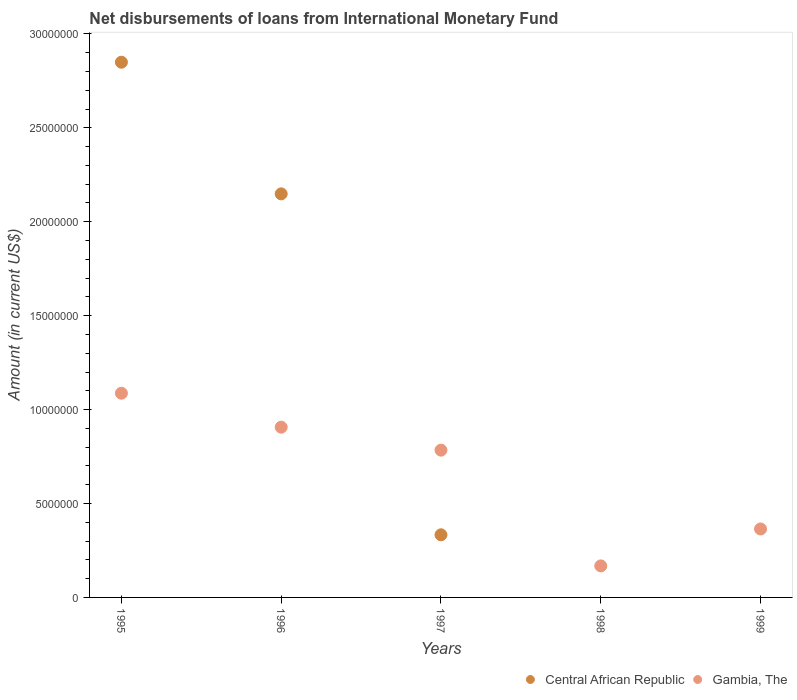Is the number of dotlines equal to the number of legend labels?
Your answer should be very brief. No. What is the amount of loans disbursed in Gambia, The in 1996?
Your response must be concise. 9.06e+06. Across all years, what is the maximum amount of loans disbursed in Central African Republic?
Provide a succinct answer. 2.85e+07. Across all years, what is the minimum amount of loans disbursed in Gambia, The?
Make the answer very short. 1.68e+06. What is the total amount of loans disbursed in Gambia, The in the graph?
Give a very brief answer. 3.31e+07. What is the difference between the amount of loans disbursed in Gambia, The in 1997 and that in 1999?
Provide a short and direct response. 4.20e+06. What is the difference between the amount of loans disbursed in Central African Republic in 1997 and the amount of loans disbursed in Gambia, The in 1995?
Make the answer very short. -7.54e+06. What is the average amount of loans disbursed in Gambia, The per year?
Your response must be concise. 6.62e+06. In the year 1997, what is the difference between the amount of loans disbursed in Central African Republic and amount of loans disbursed in Gambia, The?
Your answer should be compact. -4.51e+06. What is the ratio of the amount of loans disbursed in Gambia, The in 1996 to that in 1998?
Provide a short and direct response. 5.4. What is the difference between the highest and the second highest amount of loans disbursed in Gambia, The?
Offer a terse response. 1.81e+06. What is the difference between the highest and the lowest amount of loans disbursed in Central African Republic?
Keep it short and to the point. 2.85e+07. How many dotlines are there?
Your answer should be very brief. 2. How many years are there in the graph?
Offer a very short reply. 5. What is the difference between two consecutive major ticks on the Y-axis?
Provide a succinct answer. 5.00e+06. Does the graph contain grids?
Your response must be concise. No. Where does the legend appear in the graph?
Keep it short and to the point. Bottom right. How many legend labels are there?
Offer a very short reply. 2. How are the legend labels stacked?
Provide a succinct answer. Horizontal. What is the title of the graph?
Keep it short and to the point. Net disbursements of loans from International Monetary Fund. Does "Japan" appear as one of the legend labels in the graph?
Provide a short and direct response. No. What is the label or title of the X-axis?
Make the answer very short. Years. What is the Amount (in current US$) in Central African Republic in 1995?
Your answer should be very brief. 2.85e+07. What is the Amount (in current US$) in Gambia, The in 1995?
Ensure brevity in your answer.  1.09e+07. What is the Amount (in current US$) of Central African Republic in 1996?
Provide a succinct answer. 2.15e+07. What is the Amount (in current US$) of Gambia, The in 1996?
Your answer should be compact. 9.06e+06. What is the Amount (in current US$) of Central African Republic in 1997?
Make the answer very short. 3.33e+06. What is the Amount (in current US$) in Gambia, The in 1997?
Offer a terse response. 7.84e+06. What is the Amount (in current US$) in Gambia, The in 1998?
Make the answer very short. 1.68e+06. What is the Amount (in current US$) of Central African Republic in 1999?
Keep it short and to the point. 0. What is the Amount (in current US$) of Gambia, The in 1999?
Your answer should be compact. 3.64e+06. Across all years, what is the maximum Amount (in current US$) in Central African Republic?
Give a very brief answer. 2.85e+07. Across all years, what is the maximum Amount (in current US$) of Gambia, The?
Make the answer very short. 1.09e+07. Across all years, what is the minimum Amount (in current US$) in Central African Republic?
Your answer should be compact. 0. Across all years, what is the minimum Amount (in current US$) of Gambia, The?
Provide a short and direct response. 1.68e+06. What is the total Amount (in current US$) in Central African Republic in the graph?
Ensure brevity in your answer.  5.33e+07. What is the total Amount (in current US$) of Gambia, The in the graph?
Your answer should be compact. 3.31e+07. What is the difference between the Amount (in current US$) in Central African Republic in 1995 and that in 1996?
Provide a succinct answer. 7.01e+06. What is the difference between the Amount (in current US$) of Gambia, The in 1995 and that in 1996?
Offer a terse response. 1.81e+06. What is the difference between the Amount (in current US$) in Central African Republic in 1995 and that in 1997?
Make the answer very short. 2.52e+07. What is the difference between the Amount (in current US$) of Gambia, The in 1995 and that in 1997?
Offer a very short reply. 3.03e+06. What is the difference between the Amount (in current US$) in Gambia, The in 1995 and that in 1998?
Your response must be concise. 9.19e+06. What is the difference between the Amount (in current US$) of Gambia, The in 1995 and that in 1999?
Your response must be concise. 7.23e+06. What is the difference between the Amount (in current US$) of Central African Republic in 1996 and that in 1997?
Provide a succinct answer. 1.82e+07. What is the difference between the Amount (in current US$) in Gambia, The in 1996 and that in 1997?
Provide a short and direct response. 1.22e+06. What is the difference between the Amount (in current US$) of Gambia, The in 1996 and that in 1998?
Make the answer very short. 7.38e+06. What is the difference between the Amount (in current US$) of Gambia, The in 1996 and that in 1999?
Give a very brief answer. 5.42e+06. What is the difference between the Amount (in current US$) in Gambia, The in 1997 and that in 1998?
Make the answer very short. 6.16e+06. What is the difference between the Amount (in current US$) of Gambia, The in 1997 and that in 1999?
Your response must be concise. 4.20e+06. What is the difference between the Amount (in current US$) of Gambia, The in 1998 and that in 1999?
Your answer should be compact. -1.97e+06. What is the difference between the Amount (in current US$) of Central African Republic in 1995 and the Amount (in current US$) of Gambia, The in 1996?
Your answer should be compact. 1.94e+07. What is the difference between the Amount (in current US$) of Central African Republic in 1995 and the Amount (in current US$) of Gambia, The in 1997?
Offer a terse response. 2.07e+07. What is the difference between the Amount (in current US$) in Central African Republic in 1995 and the Amount (in current US$) in Gambia, The in 1998?
Provide a short and direct response. 2.68e+07. What is the difference between the Amount (in current US$) in Central African Republic in 1995 and the Amount (in current US$) in Gambia, The in 1999?
Your answer should be very brief. 2.48e+07. What is the difference between the Amount (in current US$) of Central African Republic in 1996 and the Amount (in current US$) of Gambia, The in 1997?
Provide a succinct answer. 1.36e+07. What is the difference between the Amount (in current US$) of Central African Republic in 1996 and the Amount (in current US$) of Gambia, The in 1998?
Your answer should be compact. 1.98e+07. What is the difference between the Amount (in current US$) of Central African Republic in 1996 and the Amount (in current US$) of Gambia, The in 1999?
Your answer should be very brief. 1.78e+07. What is the difference between the Amount (in current US$) of Central African Republic in 1997 and the Amount (in current US$) of Gambia, The in 1998?
Ensure brevity in your answer.  1.66e+06. What is the difference between the Amount (in current US$) in Central African Republic in 1997 and the Amount (in current US$) in Gambia, The in 1999?
Offer a terse response. -3.11e+05. What is the average Amount (in current US$) of Central African Republic per year?
Your response must be concise. 1.07e+07. What is the average Amount (in current US$) of Gambia, The per year?
Keep it short and to the point. 6.62e+06. In the year 1995, what is the difference between the Amount (in current US$) in Central African Republic and Amount (in current US$) in Gambia, The?
Keep it short and to the point. 1.76e+07. In the year 1996, what is the difference between the Amount (in current US$) of Central African Republic and Amount (in current US$) of Gambia, The?
Ensure brevity in your answer.  1.24e+07. In the year 1997, what is the difference between the Amount (in current US$) in Central African Republic and Amount (in current US$) in Gambia, The?
Make the answer very short. -4.51e+06. What is the ratio of the Amount (in current US$) of Central African Republic in 1995 to that in 1996?
Offer a very short reply. 1.33. What is the ratio of the Amount (in current US$) in Gambia, The in 1995 to that in 1996?
Your response must be concise. 1.2. What is the ratio of the Amount (in current US$) of Central African Republic in 1995 to that in 1997?
Ensure brevity in your answer.  8.55. What is the ratio of the Amount (in current US$) of Gambia, The in 1995 to that in 1997?
Give a very brief answer. 1.39. What is the ratio of the Amount (in current US$) of Gambia, The in 1995 to that in 1998?
Keep it short and to the point. 6.48. What is the ratio of the Amount (in current US$) in Gambia, The in 1995 to that in 1999?
Give a very brief answer. 2.98. What is the ratio of the Amount (in current US$) of Central African Republic in 1996 to that in 1997?
Offer a very short reply. 6.44. What is the ratio of the Amount (in current US$) in Gambia, The in 1996 to that in 1997?
Provide a succinct answer. 1.16. What is the ratio of the Amount (in current US$) in Gambia, The in 1996 to that in 1998?
Your answer should be very brief. 5.4. What is the ratio of the Amount (in current US$) of Gambia, The in 1996 to that in 1999?
Make the answer very short. 2.49. What is the ratio of the Amount (in current US$) of Gambia, The in 1997 to that in 1998?
Your response must be concise. 4.67. What is the ratio of the Amount (in current US$) in Gambia, The in 1997 to that in 1999?
Your response must be concise. 2.15. What is the ratio of the Amount (in current US$) in Gambia, The in 1998 to that in 1999?
Your answer should be very brief. 0.46. What is the difference between the highest and the second highest Amount (in current US$) in Central African Republic?
Provide a short and direct response. 7.01e+06. What is the difference between the highest and the second highest Amount (in current US$) in Gambia, The?
Keep it short and to the point. 1.81e+06. What is the difference between the highest and the lowest Amount (in current US$) in Central African Republic?
Keep it short and to the point. 2.85e+07. What is the difference between the highest and the lowest Amount (in current US$) in Gambia, The?
Give a very brief answer. 9.19e+06. 